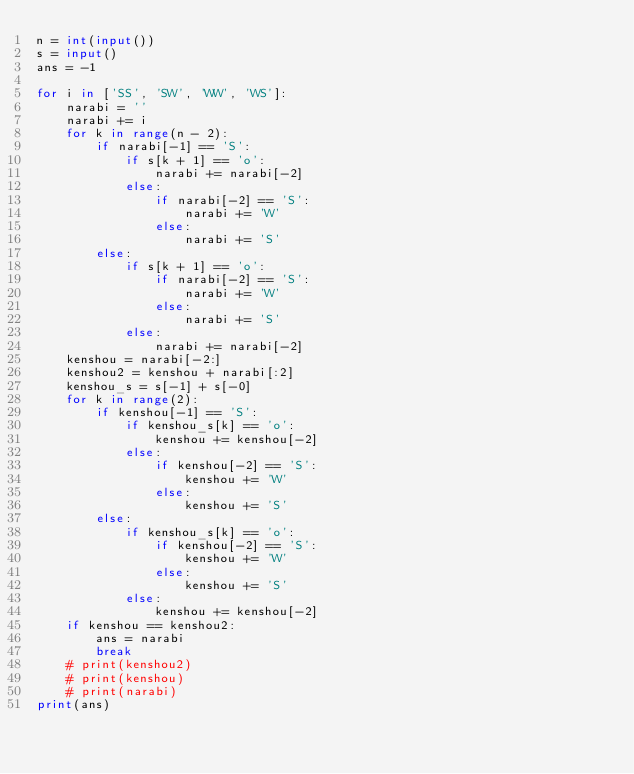<code> <loc_0><loc_0><loc_500><loc_500><_Python_>n = int(input())
s = input()
ans = -1

for i in ['SS', 'SW', 'WW', 'WS']:
    narabi = ''
    narabi += i
    for k in range(n - 2):
        if narabi[-1] == 'S':
            if s[k + 1] == 'o':
                narabi += narabi[-2]
            else:
                if narabi[-2] == 'S':
                    narabi += 'W'
                else:
                    narabi += 'S'
        else:
            if s[k + 1] == 'o':
                if narabi[-2] == 'S':
                    narabi += 'W'
                else:
                    narabi += 'S'
            else:
                narabi += narabi[-2]
    kenshou = narabi[-2:]
    kenshou2 = kenshou + narabi[:2]
    kenshou_s = s[-1] + s[-0]
    for k in range(2):
        if kenshou[-1] == 'S':
            if kenshou_s[k] == 'o':
                kenshou += kenshou[-2]
            else:
                if kenshou[-2] == 'S':
                    kenshou += 'W'
                else:
                    kenshou += 'S'
        else:
            if kenshou_s[k] == 'o':
                if kenshou[-2] == 'S':
                    kenshou += 'W'
                else:
                    kenshou += 'S'
            else:
                kenshou += kenshou[-2]
    if kenshou == kenshou2:
        ans = narabi
        break
    # print(kenshou2)
    # print(kenshou)
    # print(narabi)
print(ans)
</code> 